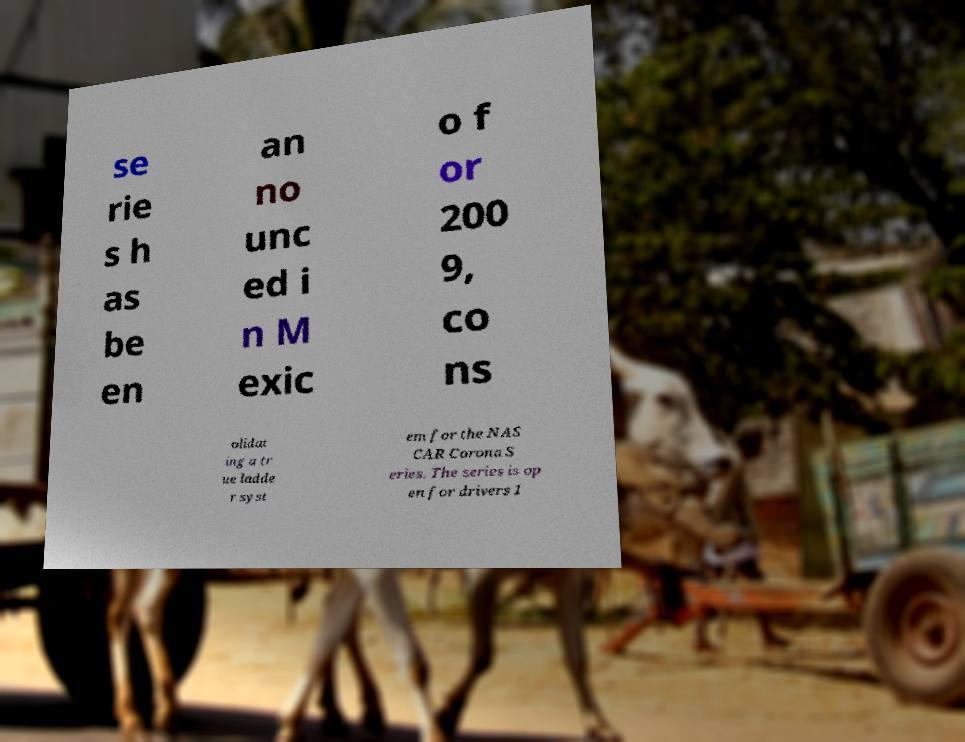For documentation purposes, I need the text within this image transcribed. Could you provide that? se rie s h as be en an no unc ed i n M exic o f or 200 9, co ns olidat ing a tr ue ladde r syst em for the NAS CAR Corona S eries. The series is op en for drivers 1 